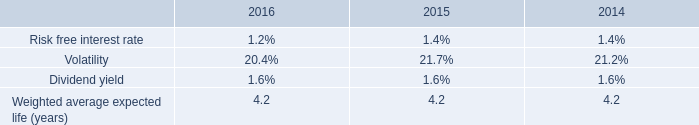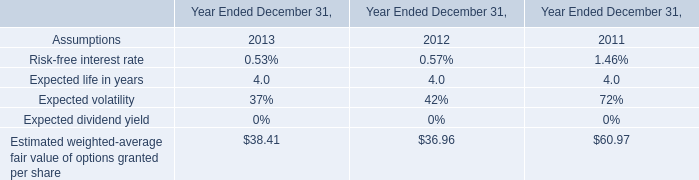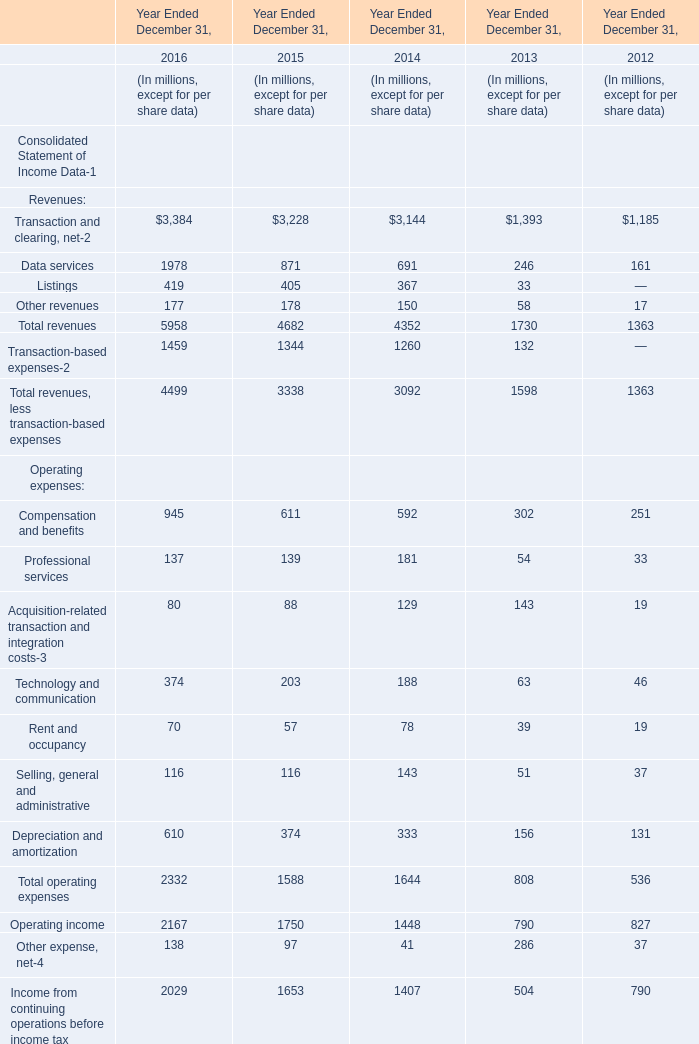What is the proportion of Listings to the total in 2016 for Revenues? 
Computations: (3384 / ((5958 + 1459) + 4499))
Answer: 0.28399. 